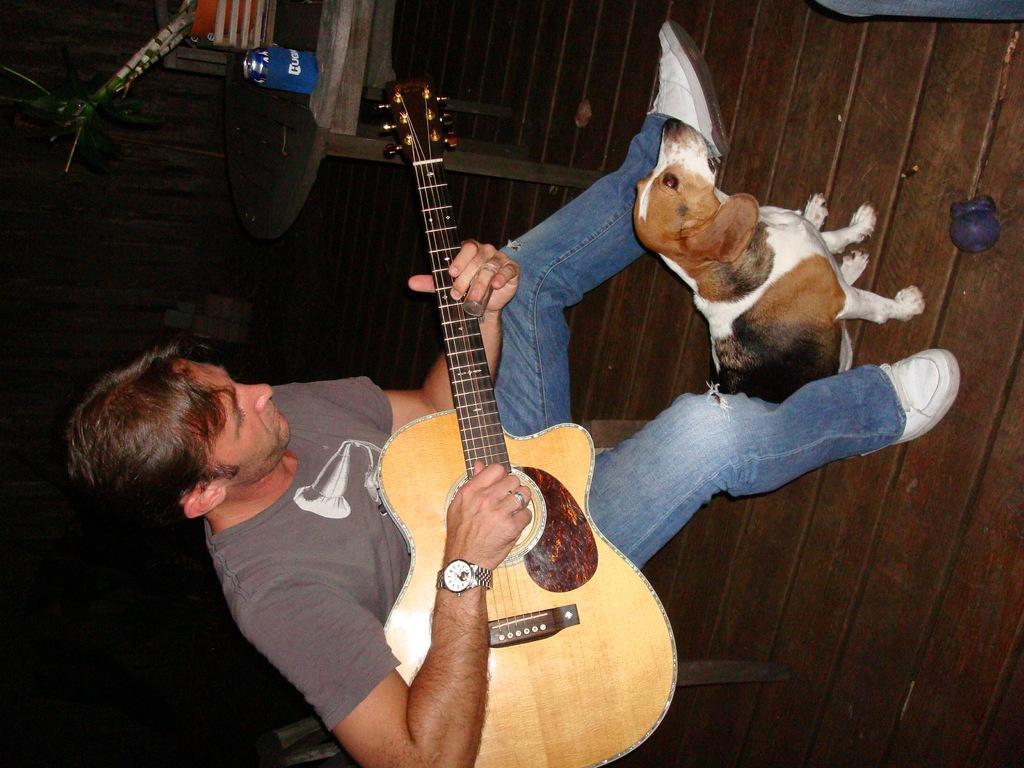In one or two sentences, can you explain what this image depicts? Here is the man sitting and playing guitar. This is a small dog sitting on the floor. I can see a wooden table with a bottle and few objects on it. This looks like a wooden floor. 